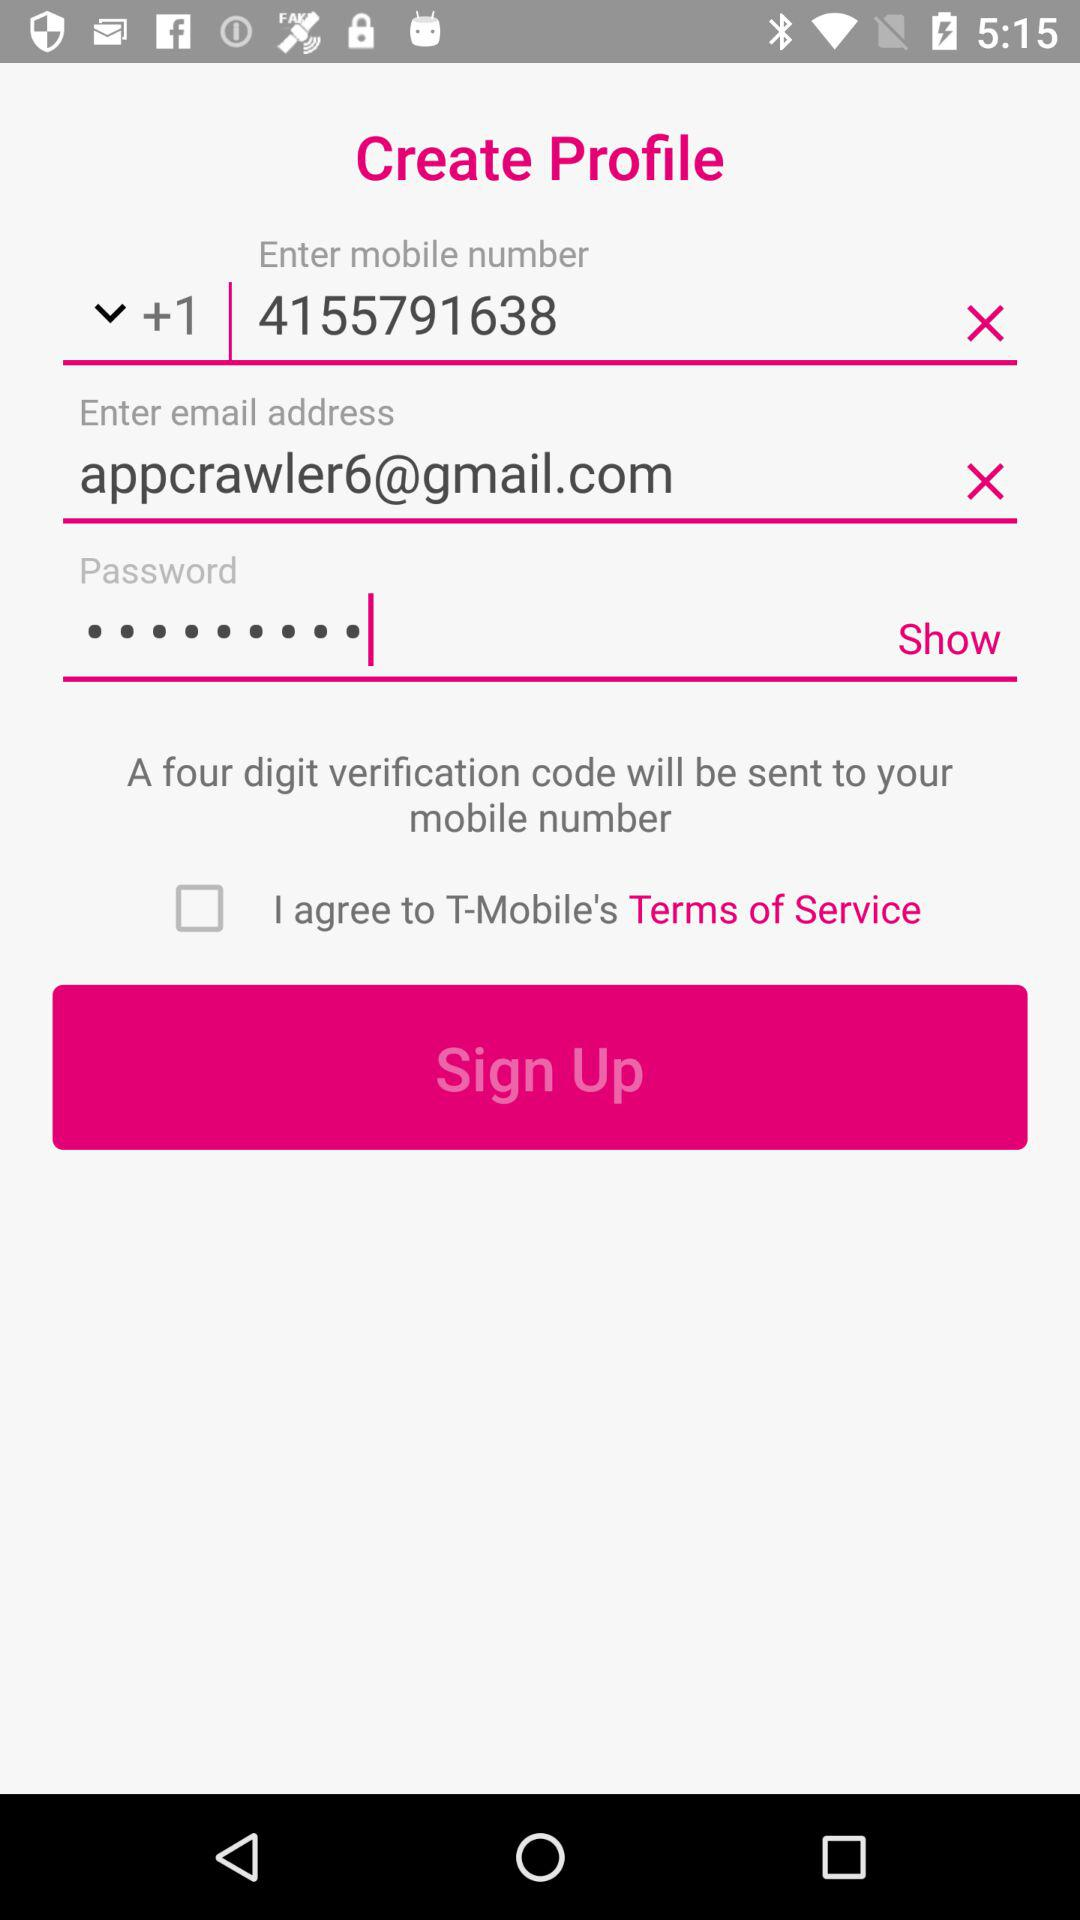What is the status of the option that includes agreement to the "Terms of Service" of "T-Mobile"? The status is "off". 